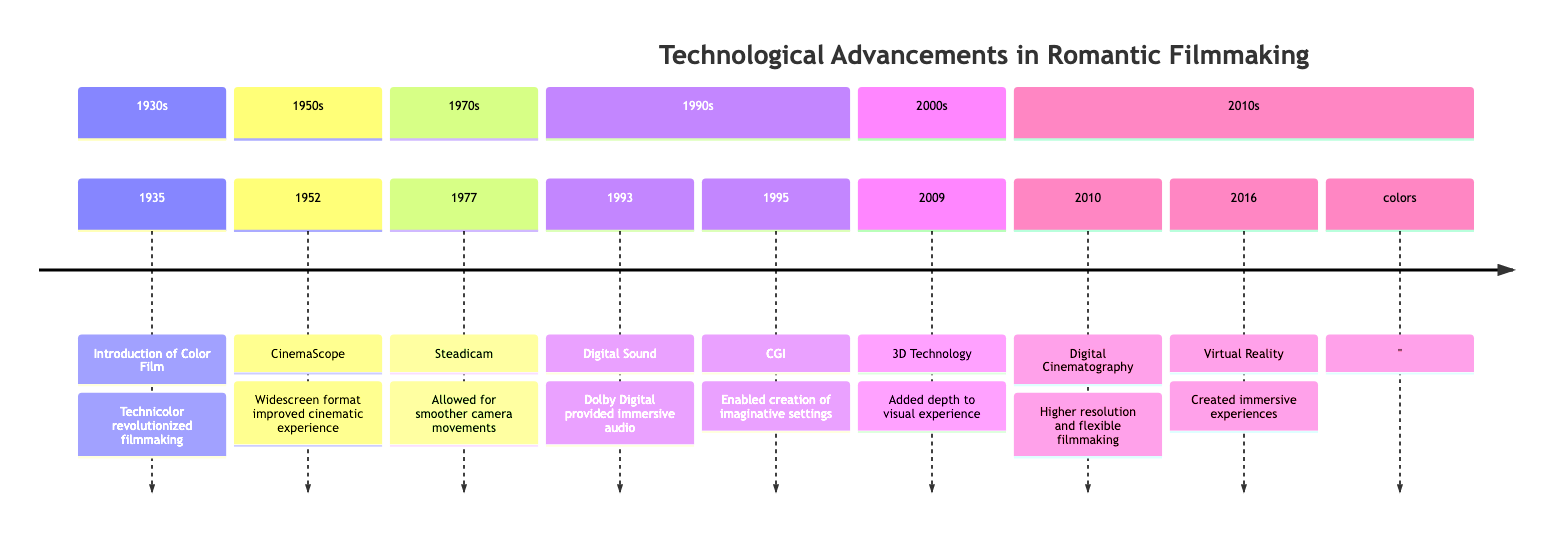What year did the introduction of color film occur? According to the timeline, the introduction of color film is listed under the year 1935.
Answer: 1935 What technology was introduced in 1952? The timeline shows that CinemaScope was introduced in the year 1952.
Answer: CinemaScope How many technological advancements are listed in the timeline? Counting the elements in the timeline, there are a total of eight technological advancements specified.
Answer: 8 What impact did the Steadicam have on filmmaking? The impact of the Steadicam, introduced in 1977, is described as allowing for smoother, more fluid camera movements.
Answer: Smoother camera movements Which technology enhanced romantic soundtracks in films? The timeline indicates that digital sound, introduced in 1993, provided clearer audio, enriching romantic soundtracks.
Answer: Digital Sound What was the major advancement in 2010? The timeline specifies that digital cinematography was the major advancement introduced in 2010.
Answer: Digital Cinematography Which two technologies improved the visual experience of romantic movies in the 2000s? Looking at the timeline, 3D technology introduced in 2009 and digital cinematography in 2010 both improved the visual experience.
Answer: 3D Technology and Digital Cinematography What impact did virtual reality technology have on the audience's experience? The timeline states that VR technology created immersive experiences, making the audience feel part of the romantic scenes.
Answer: Immersive experiences In which decade was computer-generated imagery (CGI) introduced? The timeline indicates that CGI was introduced in 1995, which falls in the 1990s decade.
Answer: 1990s 